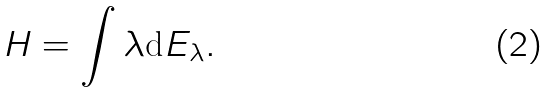<formula> <loc_0><loc_0><loc_500><loc_500>H = \int \lambda \text {d} E _ { \lambda } .</formula> 